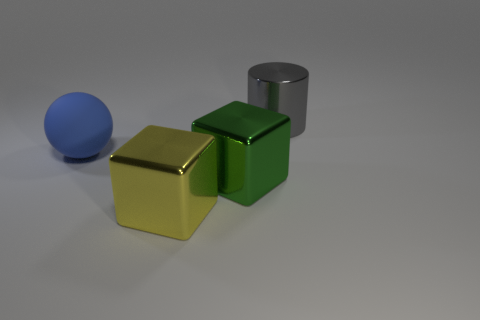Subtract 1 blocks. How many blocks are left? 1 Add 2 big gray cylinders. How many objects exist? 6 Subtract all yellow cubes. How many cubes are left? 1 Subtract all cyan balls. Subtract all gray cylinders. How many balls are left? 1 Subtract all blue cylinders. How many green blocks are left? 1 Subtract all purple shiny objects. Subtract all large cylinders. How many objects are left? 3 Add 3 blue balls. How many blue balls are left? 4 Add 3 shiny things. How many shiny things exist? 6 Subtract 0 red cylinders. How many objects are left? 4 Subtract all cylinders. How many objects are left? 3 